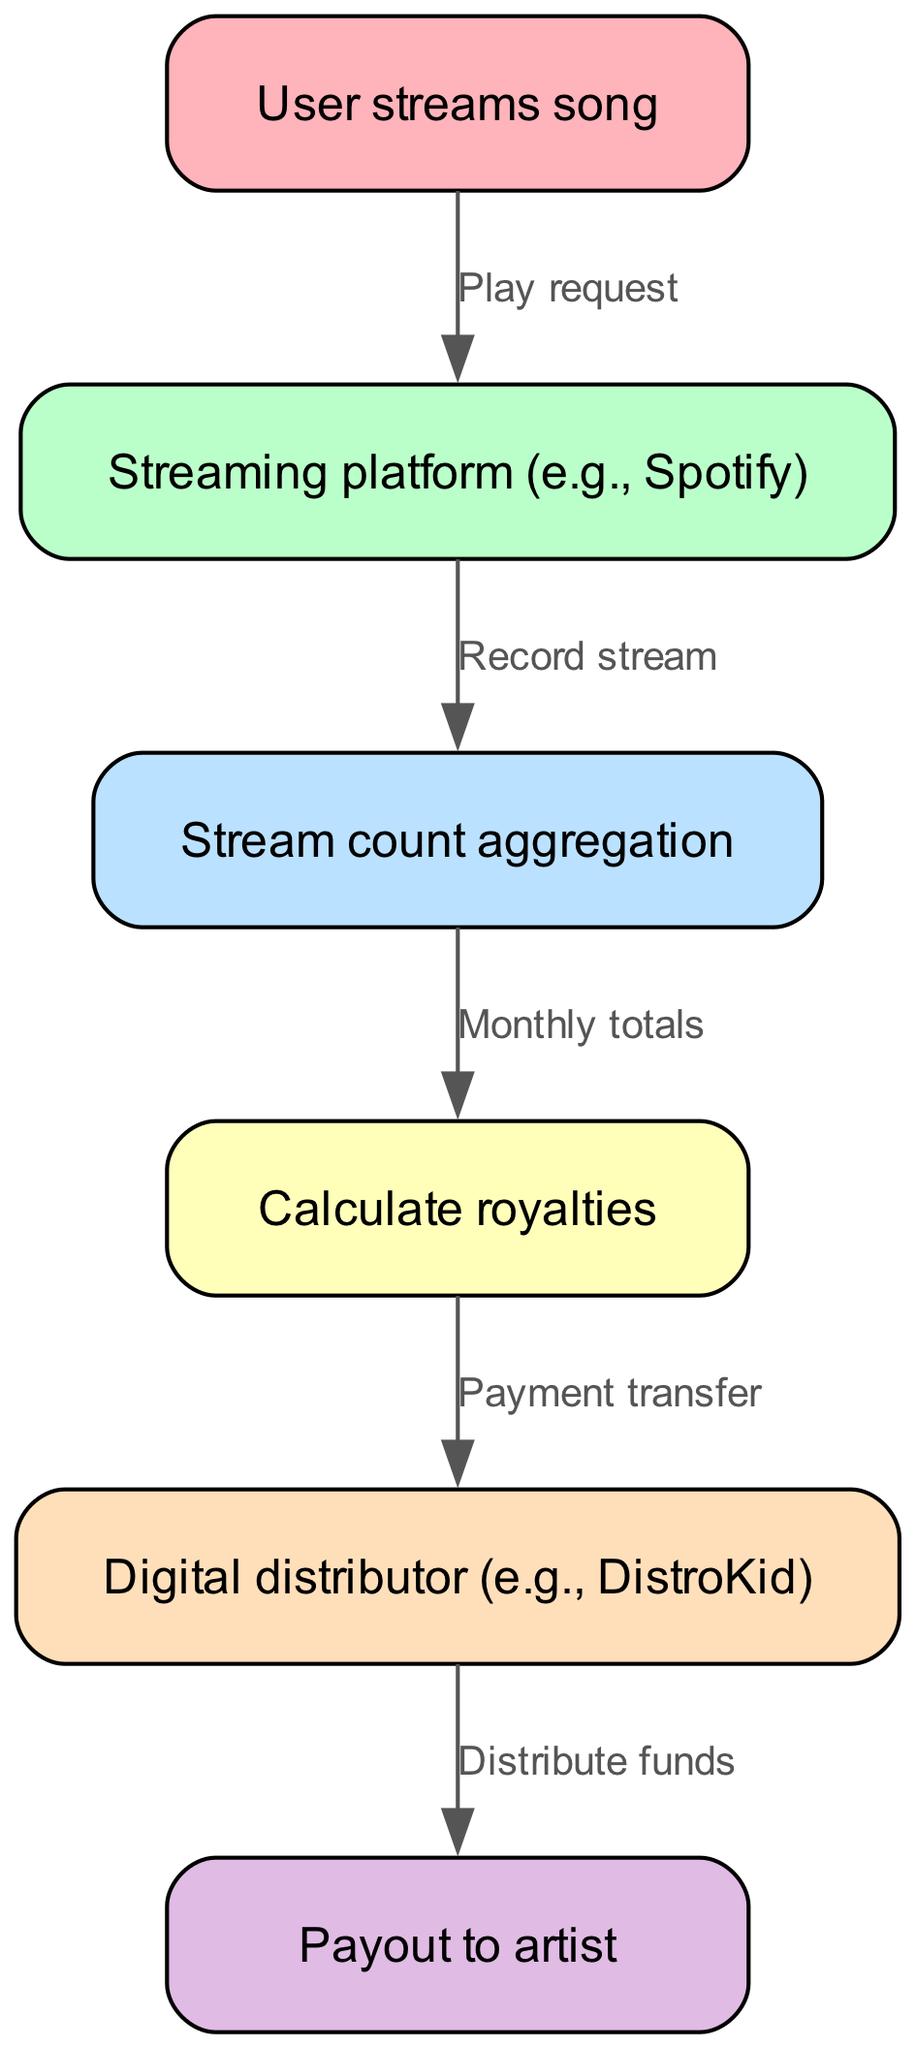What triggers the royalty calculation process? The process begins when a user plays a song, which is represented by the "User streams song" node. This is the first node in the flowchart that initiates the subsequent steps.
Answer: User streams song How many edges are there in the diagram? The diagram contains five edges that represent the flow of information between the nodes. Each edge corresponds to a relationship between two processes in the royalty calculation workflow.
Answer: 5 What is the role of the digital distributor? The digital distributor is responsible for transferring the calculated royalties to the artist after the streaming platform records stream counts and calculates royalties. This is indicated by the edge labeled "Payment transfer."
Answer: Payment transfer What happens after the streaming platform records streams? After the streaming platform records the streams, the data is aggregated in a node labeled "Stream count aggregation," which collects the total streams before moving on to royalty calculation.
Answer: Stream count aggregation Which node comes before the payout to the artist? The node that comes before the payout to the artist is "Digital distributor," where funds are prepared for distribution to the artist. This is depicted in the diagram by the edge labeled "Distribute funds."
Answer: Digital distributor How is the payout to the artist initiated? The payout to the artist is initiated once the digital distributor distributes the funds calculated from the royalties; this is shown as the final node in the workflow.
Answer: Distribute funds What is the first action in the workflow? The first action in the workflow is represented by the node "User streams song," which indicates that the process starts with a song being played by a user on the streaming platform.
Answer: User streams song What does the edge from "Stream count aggregation" to "Calculate royalties" signify? The edge signifies that the total number of streams recorded is processed to calculate the royalties owed to the artist based on the aggregated stream counts for that period.
Answer: Calculate royalties What is the last step in the royalty calculation workflow? The last step in the workflow is the "Payout to artist," which represents the final action of distributing the calculated royalties to the music creator after all prior calculations and transfers.
Answer: Payout to artist 